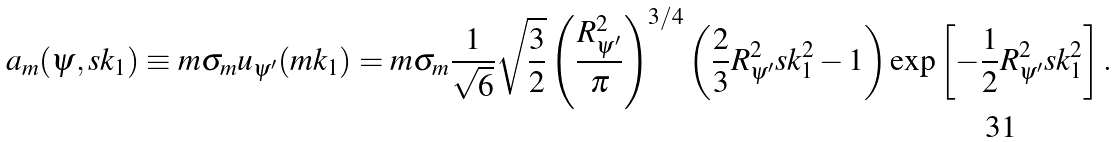Convert formula to latex. <formula><loc_0><loc_0><loc_500><loc_500>a _ { m } ( \psi , s k _ { 1 } ) \equiv m \sigma _ { m } u _ { \psi ^ { \prime } } ( m { k _ { 1 } } ) = m \sigma _ { m } \frac { 1 } { \sqrt { 6 } } { \sqrt { \frac { 3 } { 2 } } } \left ( { \frac { R _ { \psi ^ { \prime } } ^ { 2 } } { \pi } } \right ) ^ { 3 / 4 } \left ( \frac { 2 } { 3 } R _ { \psi ^ { \prime } } ^ { 2 } s k _ { 1 } ^ { 2 } - 1 \right ) \exp \left [ - \frac { 1 } { 2 } R _ { \psi ^ { \prime } } ^ { 2 } s k _ { 1 } ^ { 2 } \right ] .</formula> 